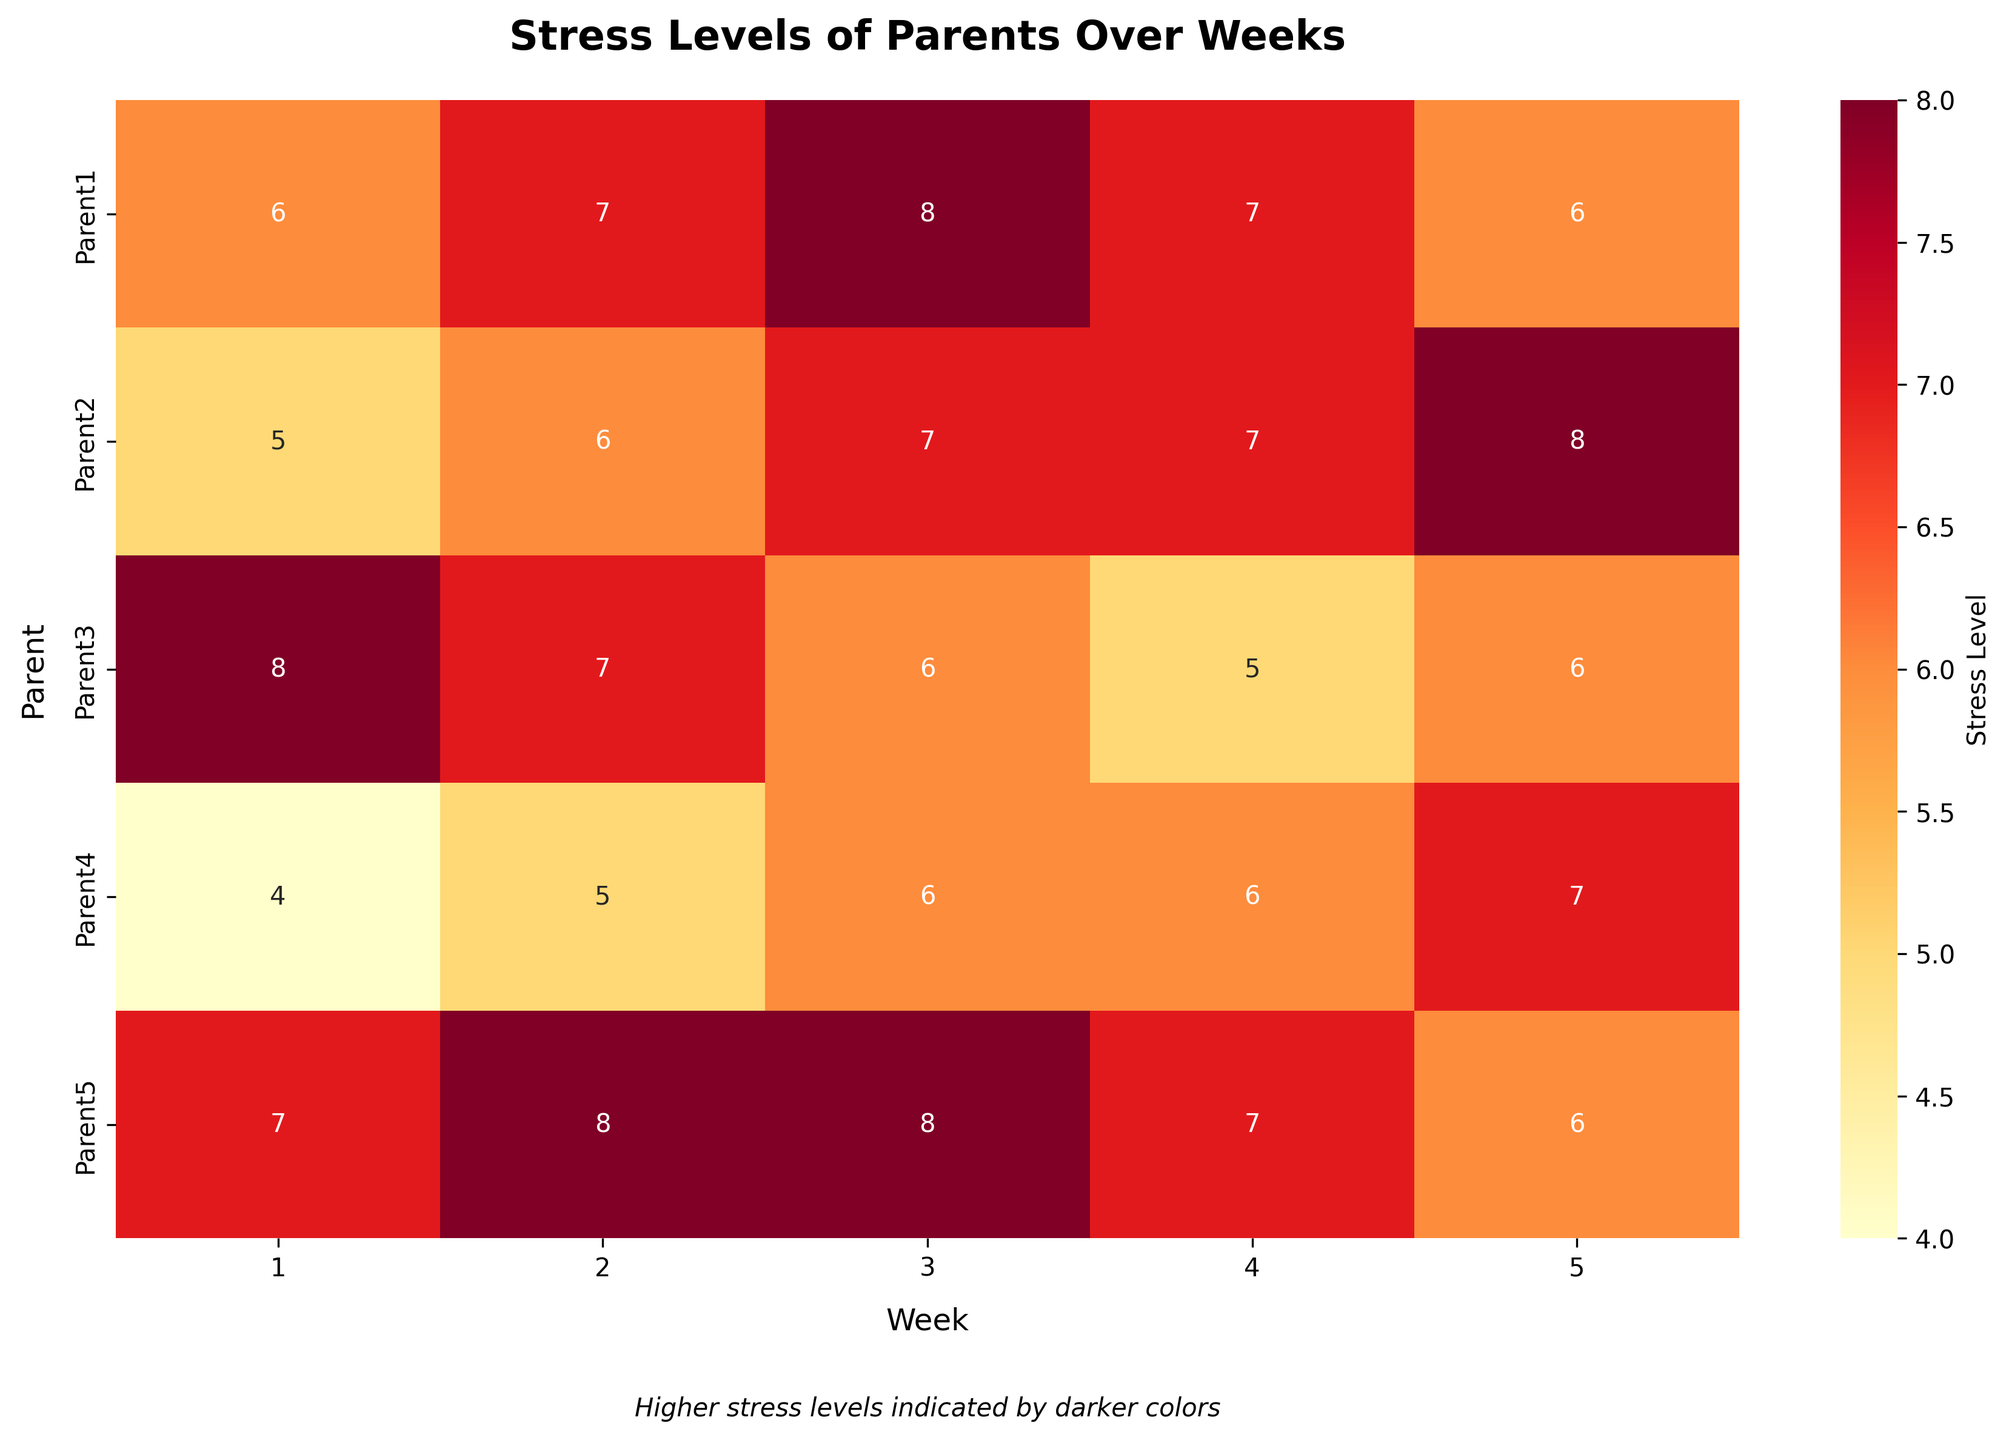What is the highest stress level recorded across all parents and weeks? To find the highest stress level, look at the numbers in the heatmap. The darkest colors represent the highest stress. The highest number observed is 8.
Answer: 8 Which parent had the most consistent stress levels over the five weeks? Consistency can be observed through comparing the variability of stress levels for each parent across the weeks. Parent3’s stress levels (8, 7, 6, 5, 6) vary in a more consistent and gradual manner than others.
Answer: Parent3 What is the average stress level for Parent1 over the weeks? Calculate the average of Parent1's stress levels: (6 + 7 + 8 + 7 + 6)/5 = 34/5.
Answer: 6.8 Which week shows the highest stress level on average across all parents? To find this, average the stress levels for each week: 
Week 1: (6 + 5 + 8 + 4 + 7)/5 = 6 
Week 2: (7 + 6 + 7 + 5 + 8)/5 = 6.6 
Week 3: (8 + 7 + 6 + 6 + 8)/5 = 7 
Week 4: (7 + 7 + 5 + 6 + 7)/5 = 6.4 
Week 5: (6 + 8 + 6 + 7 + 6)/5 = 6.6. 
Week 3 has the highest average stress level.
Answer: Week 3 Which parent experienced the highest reduction in stress level from the first to the fifth week? Calculate the difference in stress levels between Week1 and Week5 for each parent: 
Parent1: 6 - 6 = 0, 
Parent2: 5 - 8 = -3, 
Parent3: 8 - 6 = 2, 
Parent4: 4 - 7 = -3, 
Parent5: 7 - 6 = 1. 
Although Parent2 and Parent4 had reductions, they had negative values, indicating an increase. Parent3 had the highest reduction with a value of 2.
Answer: Parent3 In which week is Parent4’s stress level the lowest? Locate Parent4’s stress levels on the heatmap across the weeks. The lowest value among (4, 5, 6, 6, 7) is 4, which occurs in Week 1.
Answer: Week 1 Which parent had the highest stress level during Week 4? Compare the stress levels of all parents for Week 4. Parent5 and Parent1 both have a value of 7, showing the highest stress level.
Answer: Parent1 and Parent5 How many parents have a stress level of 6 in Week 3? Look at Week 3 column; stress level 6 appears for Parent3 and Parent4, totaling 2 parents.
Answer: 2 